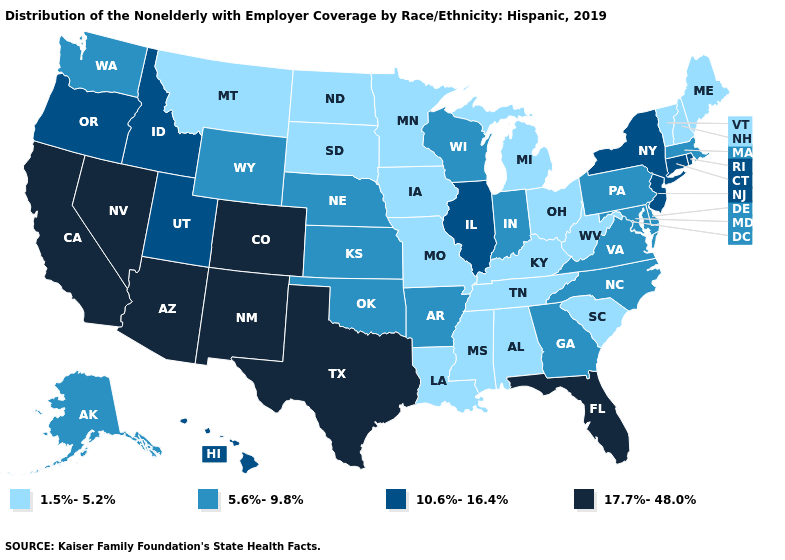Which states have the lowest value in the West?
Short answer required. Montana. Name the states that have a value in the range 5.6%-9.8%?
Concise answer only. Alaska, Arkansas, Delaware, Georgia, Indiana, Kansas, Maryland, Massachusetts, Nebraska, North Carolina, Oklahoma, Pennsylvania, Virginia, Washington, Wisconsin, Wyoming. What is the value of Maine?
Concise answer only. 1.5%-5.2%. What is the highest value in states that border Pennsylvania?
Give a very brief answer. 10.6%-16.4%. Name the states that have a value in the range 5.6%-9.8%?
Be succinct. Alaska, Arkansas, Delaware, Georgia, Indiana, Kansas, Maryland, Massachusetts, Nebraska, North Carolina, Oklahoma, Pennsylvania, Virginia, Washington, Wisconsin, Wyoming. What is the value of Kansas?
Answer briefly. 5.6%-9.8%. What is the highest value in the USA?
Be succinct. 17.7%-48.0%. Does Rhode Island have a higher value than Hawaii?
Answer briefly. No. Does Virginia have the same value as Tennessee?
Be succinct. No. Name the states that have a value in the range 5.6%-9.8%?
Write a very short answer. Alaska, Arkansas, Delaware, Georgia, Indiana, Kansas, Maryland, Massachusetts, Nebraska, North Carolina, Oklahoma, Pennsylvania, Virginia, Washington, Wisconsin, Wyoming. Name the states that have a value in the range 10.6%-16.4%?
Quick response, please. Connecticut, Hawaii, Idaho, Illinois, New Jersey, New York, Oregon, Rhode Island, Utah. Does Tennessee have a lower value than Alaska?
Keep it brief. Yes. What is the lowest value in the MidWest?
Short answer required. 1.5%-5.2%. What is the value of California?
Quick response, please. 17.7%-48.0%. What is the value of Tennessee?
Write a very short answer. 1.5%-5.2%. 